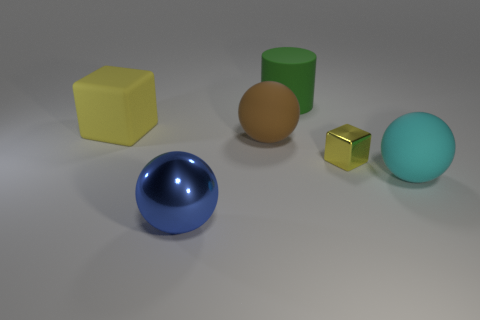Can you tell me about the colors of the objects in this image? Certainly! In the image, there are objects of various colors including a yellow cube, a green cylinder, a blue sphere, a brown hemisphere, a golden cube, and a turquoise sphere. 